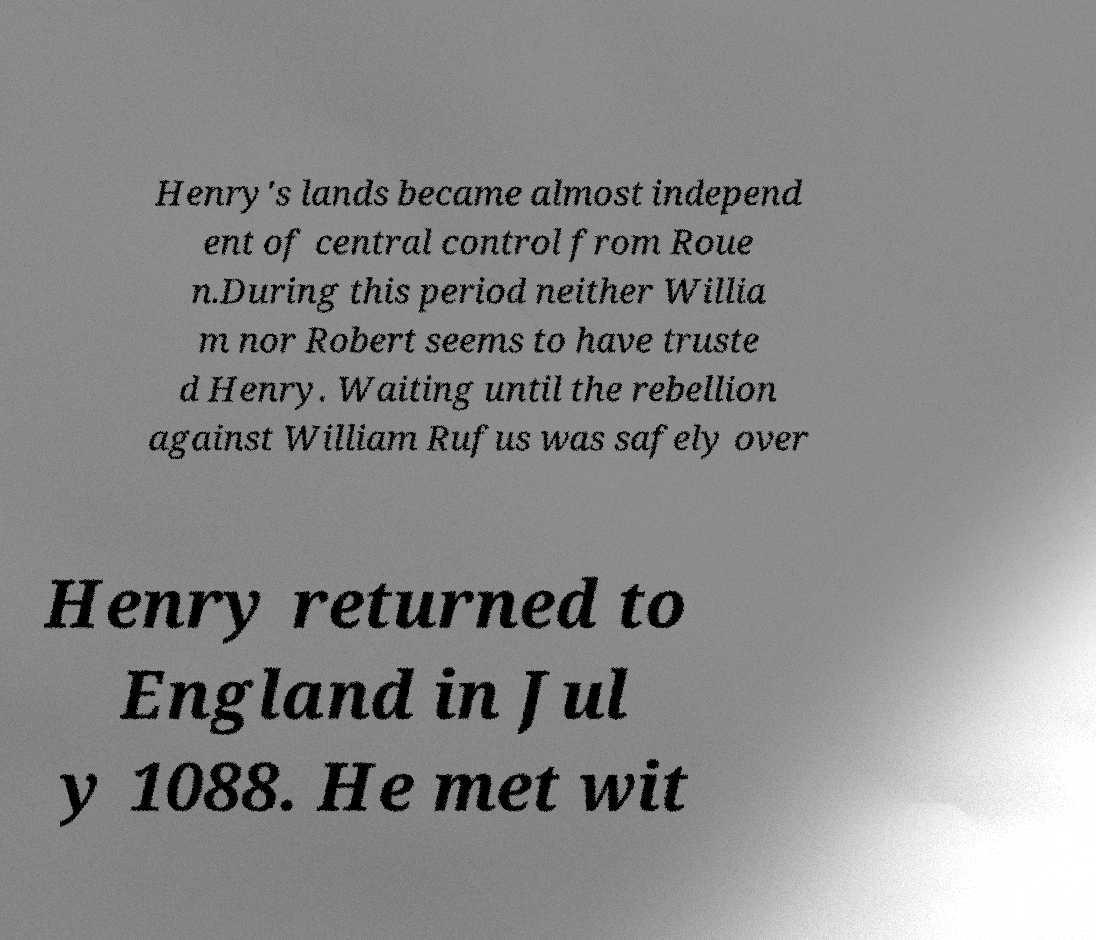For documentation purposes, I need the text within this image transcribed. Could you provide that? Henry's lands became almost independ ent of central control from Roue n.During this period neither Willia m nor Robert seems to have truste d Henry. Waiting until the rebellion against William Rufus was safely over Henry returned to England in Jul y 1088. He met wit 